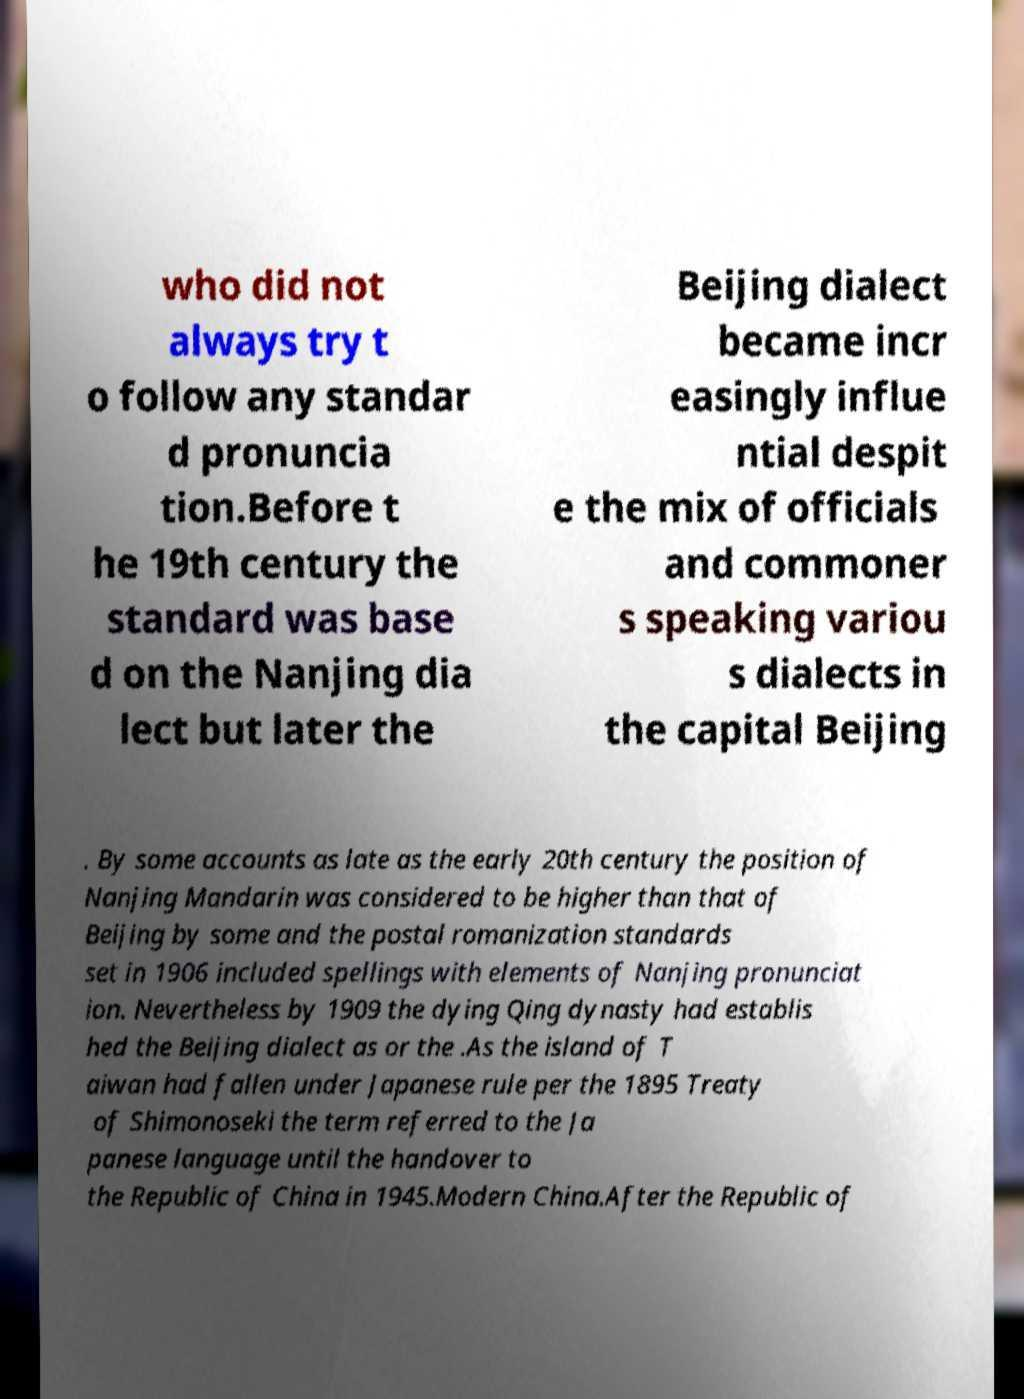Can you read and provide the text displayed in the image?This photo seems to have some interesting text. Can you extract and type it out for me? who did not always try t o follow any standar d pronuncia tion.Before t he 19th century the standard was base d on the Nanjing dia lect but later the Beijing dialect became incr easingly influe ntial despit e the mix of officials and commoner s speaking variou s dialects in the capital Beijing . By some accounts as late as the early 20th century the position of Nanjing Mandarin was considered to be higher than that of Beijing by some and the postal romanization standards set in 1906 included spellings with elements of Nanjing pronunciat ion. Nevertheless by 1909 the dying Qing dynasty had establis hed the Beijing dialect as or the .As the island of T aiwan had fallen under Japanese rule per the 1895 Treaty of Shimonoseki the term referred to the Ja panese language until the handover to the Republic of China in 1945.Modern China.After the Republic of 